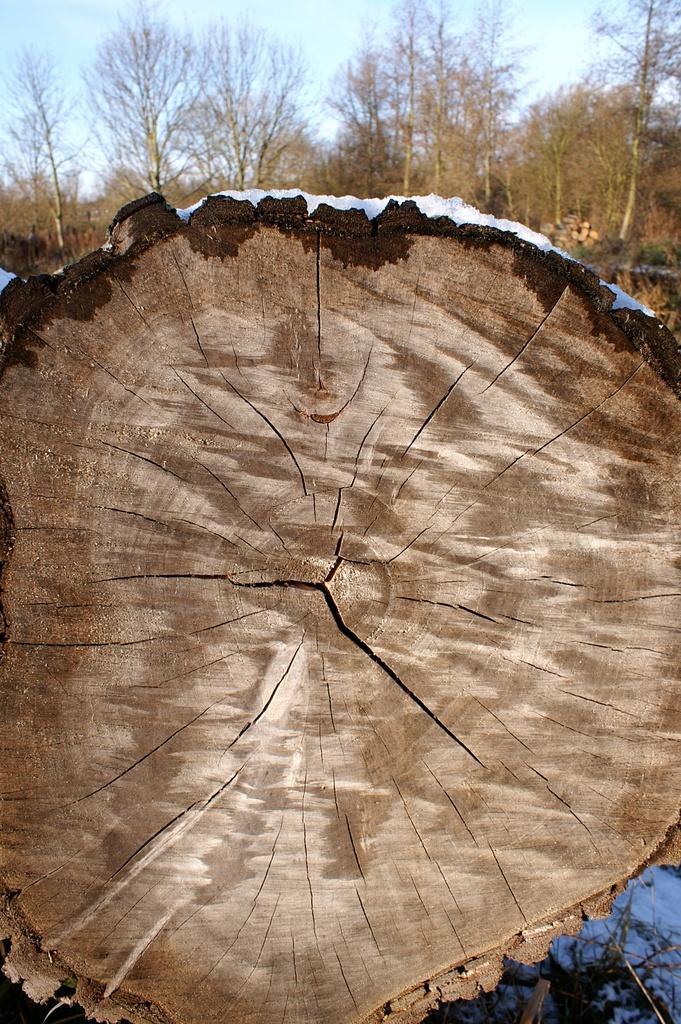How would you summarize this image in a sentence or two? In this image I can see the wooden log with snow on it. To the right I can see the sticks and snow on the ground. In the background I can see many trees and the sky. 